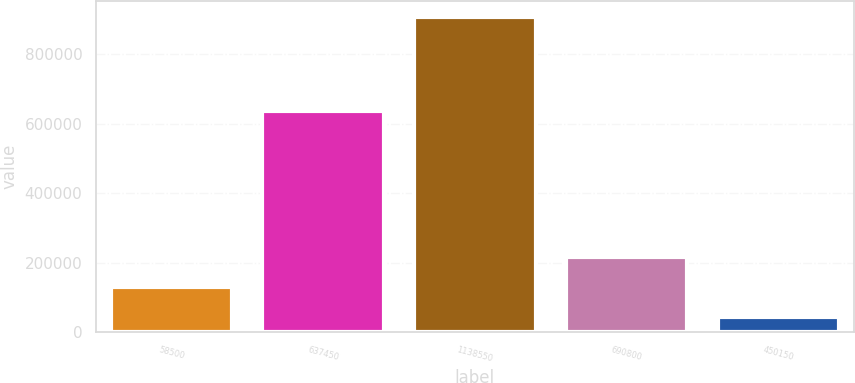Convert chart. <chart><loc_0><loc_0><loc_500><loc_500><bar_chart><fcel>58500<fcel>637450<fcel>1138550<fcel>690800<fcel>450150<nl><fcel>131929<fcel>637450<fcel>907450<fcel>218098<fcel>45760<nl></chart> 